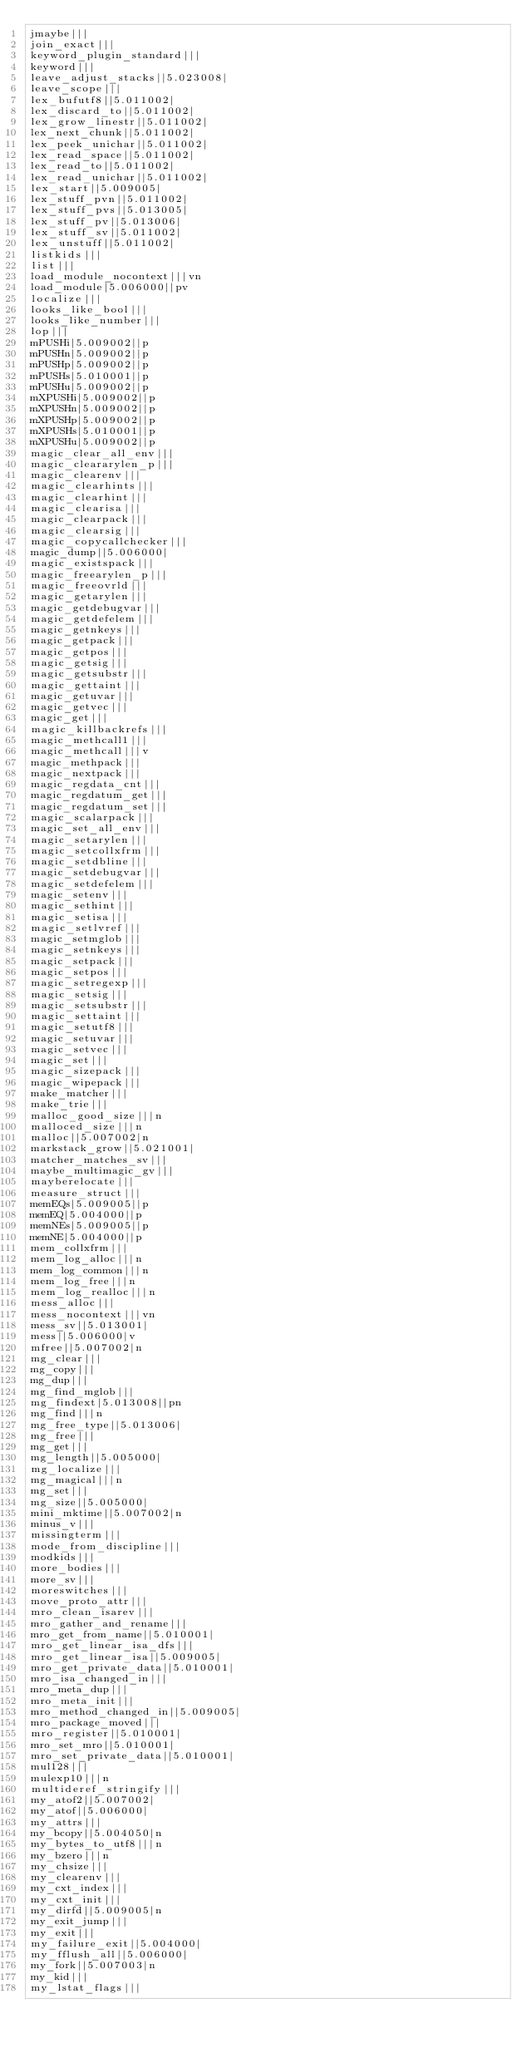<code> <loc_0><loc_0><loc_500><loc_500><_C_>jmaybe|||
join_exact|||
keyword_plugin_standard|||
keyword|||
leave_adjust_stacks||5.023008|
leave_scope|||
lex_bufutf8||5.011002|
lex_discard_to||5.011002|
lex_grow_linestr||5.011002|
lex_next_chunk||5.011002|
lex_peek_unichar||5.011002|
lex_read_space||5.011002|
lex_read_to||5.011002|
lex_read_unichar||5.011002|
lex_start||5.009005|
lex_stuff_pvn||5.011002|
lex_stuff_pvs||5.013005|
lex_stuff_pv||5.013006|
lex_stuff_sv||5.011002|
lex_unstuff||5.011002|
listkids|||
list|||
load_module_nocontext|||vn
load_module|5.006000||pv
localize|||
looks_like_bool|||
looks_like_number|||
lop|||
mPUSHi|5.009002||p
mPUSHn|5.009002||p
mPUSHp|5.009002||p
mPUSHs|5.010001||p
mPUSHu|5.009002||p
mXPUSHi|5.009002||p
mXPUSHn|5.009002||p
mXPUSHp|5.009002||p
mXPUSHs|5.010001||p
mXPUSHu|5.009002||p
magic_clear_all_env|||
magic_cleararylen_p|||
magic_clearenv|||
magic_clearhints|||
magic_clearhint|||
magic_clearisa|||
magic_clearpack|||
magic_clearsig|||
magic_copycallchecker|||
magic_dump||5.006000|
magic_existspack|||
magic_freearylen_p|||
magic_freeovrld|||
magic_getarylen|||
magic_getdebugvar|||
magic_getdefelem|||
magic_getnkeys|||
magic_getpack|||
magic_getpos|||
magic_getsig|||
magic_getsubstr|||
magic_gettaint|||
magic_getuvar|||
magic_getvec|||
magic_get|||
magic_killbackrefs|||
magic_methcall1|||
magic_methcall|||v
magic_methpack|||
magic_nextpack|||
magic_regdata_cnt|||
magic_regdatum_get|||
magic_regdatum_set|||
magic_scalarpack|||
magic_set_all_env|||
magic_setarylen|||
magic_setcollxfrm|||
magic_setdbline|||
magic_setdebugvar|||
magic_setdefelem|||
magic_setenv|||
magic_sethint|||
magic_setisa|||
magic_setlvref|||
magic_setmglob|||
magic_setnkeys|||
magic_setpack|||
magic_setpos|||
magic_setregexp|||
magic_setsig|||
magic_setsubstr|||
magic_settaint|||
magic_setutf8|||
magic_setuvar|||
magic_setvec|||
magic_set|||
magic_sizepack|||
magic_wipepack|||
make_matcher|||
make_trie|||
malloc_good_size|||n
malloced_size|||n
malloc||5.007002|n
markstack_grow||5.021001|
matcher_matches_sv|||
maybe_multimagic_gv|||
mayberelocate|||
measure_struct|||
memEQs|5.009005||p
memEQ|5.004000||p
memNEs|5.009005||p
memNE|5.004000||p
mem_collxfrm|||
mem_log_alloc|||n
mem_log_common|||n
mem_log_free|||n
mem_log_realloc|||n
mess_alloc|||
mess_nocontext|||vn
mess_sv||5.013001|
mess||5.006000|v
mfree||5.007002|n
mg_clear|||
mg_copy|||
mg_dup|||
mg_find_mglob|||
mg_findext|5.013008||pn
mg_find|||n
mg_free_type||5.013006|
mg_free|||
mg_get|||
mg_length||5.005000|
mg_localize|||
mg_magical|||n
mg_set|||
mg_size||5.005000|
mini_mktime||5.007002|n
minus_v|||
missingterm|||
mode_from_discipline|||
modkids|||
more_bodies|||
more_sv|||
moreswitches|||
move_proto_attr|||
mro_clean_isarev|||
mro_gather_and_rename|||
mro_get_from_name||5.010001|
mro_get_linear_isa_dfs|||
mro_get_linear_isa||5.009005|
mro_get_private_data||5.010001|
mro_isa_changed_in|||
mro_meta_dup|||
mro_meta_init|||
mro_method_changed_in||5.009005|
mro_package_moved|||
mro_register||5.010001|
mro_set_mro||5.010001|
mro_set_private_data||5.010001|
mul128|||
mulexp10|||n
multideref_stringify|||
my_atof2||5.007002|
my_atof||5.006000|
my_attrs|||
my_bcopy||5.004050|n
my_bytes_to_utf8|||n
my_bzero|||n
my_chsize|||
my_clearenv|||
my_cxt_index|||
my_cxt_init|||
my_dirfd||5.009005|n
my_exit_jump|||
my_exit|||
my_failure_exit||5.004000|
my_fflush_all||5.006000|
my_fork||5.007003|n
my_kid|||
my_lstat_flags|||</code> 